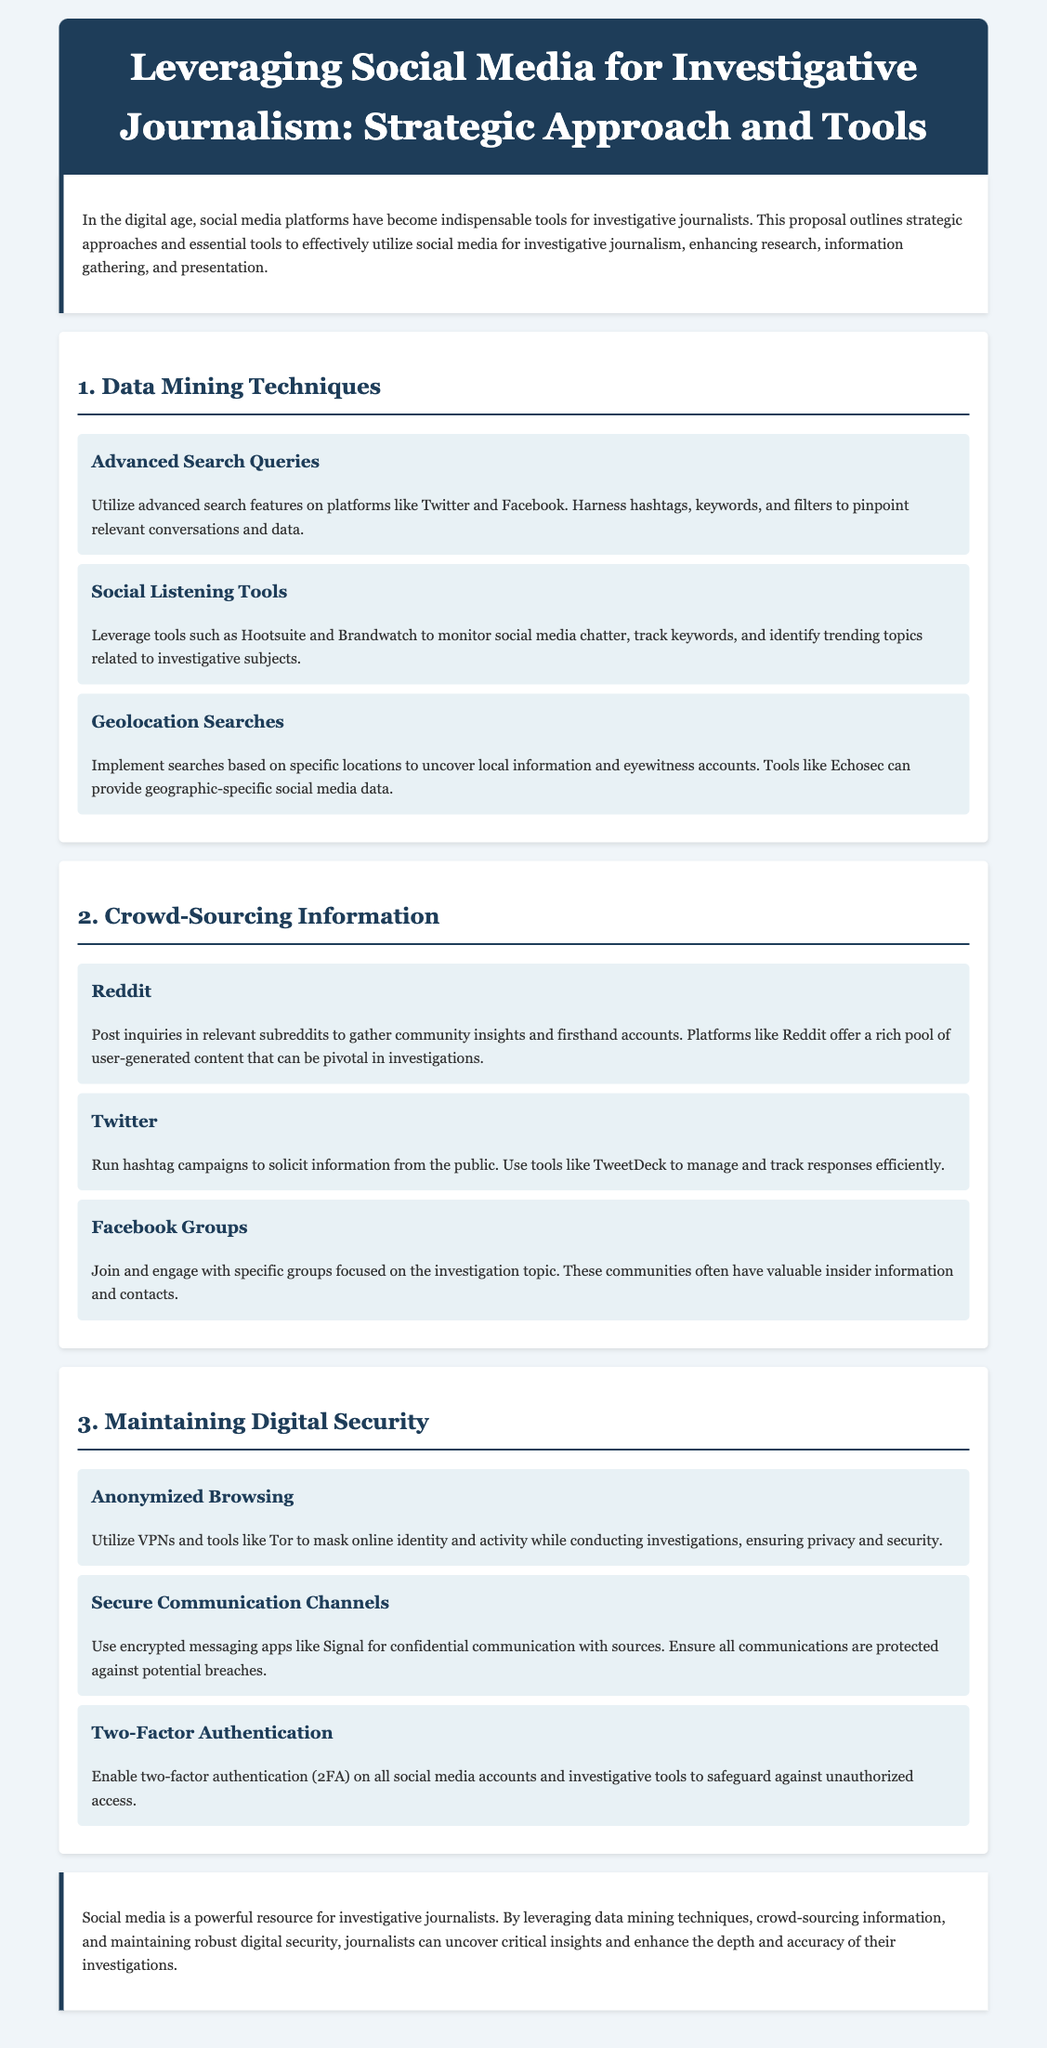What is the title of the proposal? The title is clearly stated at the beginning of the document, which outlines the focus of the proposal for journalists.
Answer: Leveraging Social Media for Investigative Journalism: Strategic Approach and Tools What is one technique for data mining mentioned? The document lists various techniques for data mining under the first section, providing specific examples journalists can use.
Answer: Advanced Search Queries Which social media platform is suggested for crowd-sourcing through inquiries? The proposal identifies platforms to solicit information and provides details on how to use them in investigative work.
Answer: Reddit What strategy is recommended for maintaining digital security? The document contains specific strategies aimed at ensuring journalists' safety while conducting investigations.
Answer: Anonymized Browsing How many strategies for digital security are outlined in the proposal? The proposal lists specific strategies to maintain digital security, allowing for a clear count.
Answer: Three What tool is suggested for monitoring social media chatter? The document mentions tools that can assist in listening and tracking online conversations relevant to investigations.
Answer: Brandwatch What section discusses crowd-sourcing information? The proposal organizes content into sections, making it easy to identify the focus areas for investigative journalism strategies.
Answer: 2. Crowd-Sourcing Information What is the purpose of using two-factor authentication? The proposal outlines important digital security measures, explicitly stating the reasoning behind each tool's use.
Answer: Safeguard against unauthorized access 